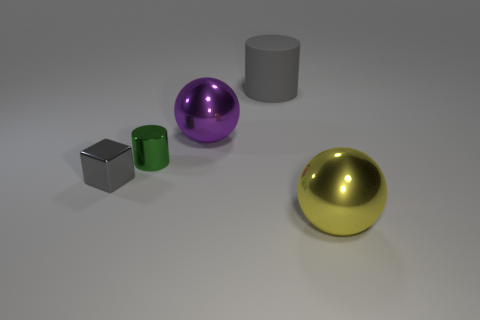Is the large yellow object the same shape as the purple object?
Keep it short and to the point. Yes. There is a green thing that is to the right of the small gray shiny object; what is its size?
Offer a very short reply. Small. What size is the gray thing that is made of the same material as the tiny green cylinder?
Your response must be concise. Small. Are there fewer tiny green rubber cylinders than spheres?
Offer a very short reply. Yes. What material is the cylinder that is the same size as the gray block?
Give a very brief answer. Metal. Are there more cylinders than gray metallic cubes?
Your answer should be compact. Yes. How many other objects are the same color as the small metal block?
Offer a terse response. 1. How many gray things are both to the right of the block and in front of the big gray rubber thing?
Make the answer very short. 0. Are there any other things that are the same size as the green cylinder?
Keep it short and to the point. Yes. Is the number of big metallic objects that are to the right of the large rubber cylinder greater than the number of large things on the right side of the small gray cube?
Your response must be concise. No. 